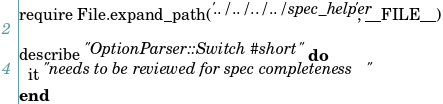Convert code to text. <code><loc_0><loc_0><loc_500><loc_500><_Ruby_>require File.expand_path('../../../../spec_helper', __FILE__)

describe "OptionParser::Switch#short" do
  it "needs to be reviewed for spec completeness"
end
</code> 